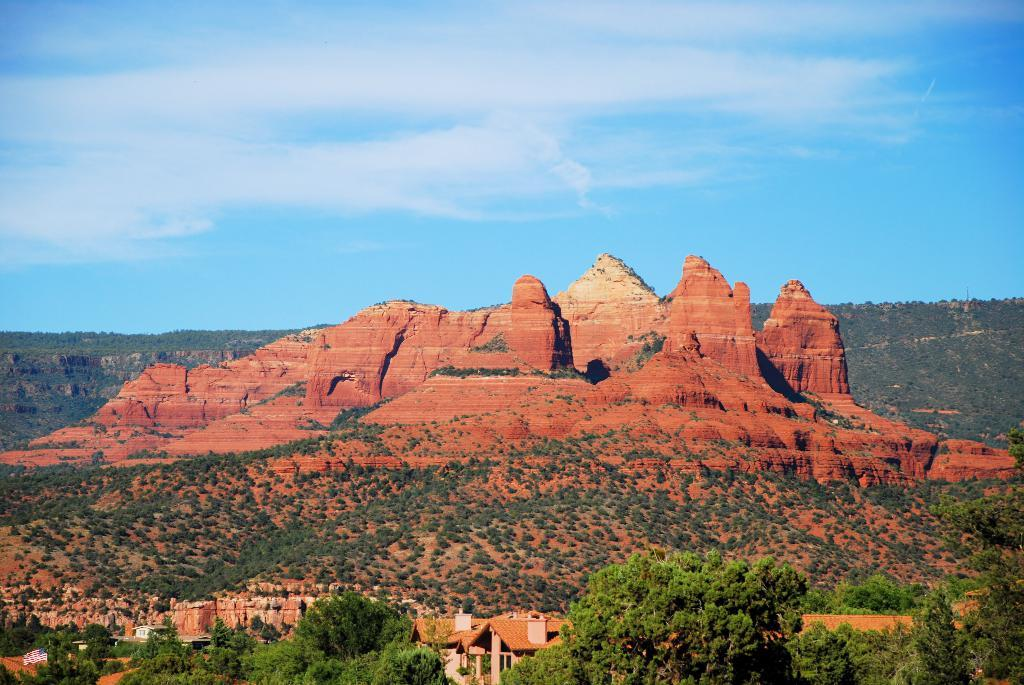What can be seen in the foreground of the image? There are trees in the foreground of the image. What is visible in the background of the image? There are buildings, trees, mountains, cliffs, and the sky in the background of the image. Can you describe the sky in the image? The sky is visible in the background of the image, and there is a cloud present. What type of hammer is being used by the beast in the image? There is no beast or hammer present in the image. What reason does the cloud have for being in the sky in the image? Clouds form naturally in the atmosphere and do not have reasons for being in the sky. 